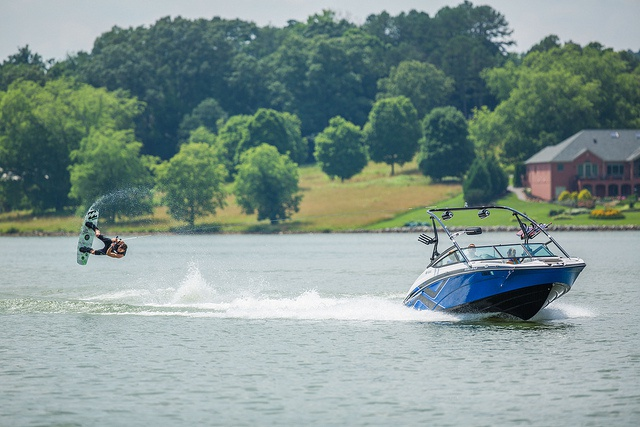Describe the objects in this image and their specific colors. I can see boat in darkgray, black, lightgray, and navy tones, people in darkgray, black, and gray tones, people in darkgray, lightgray, and lightblue tones, and people in darkgray and gray tones in this image. 